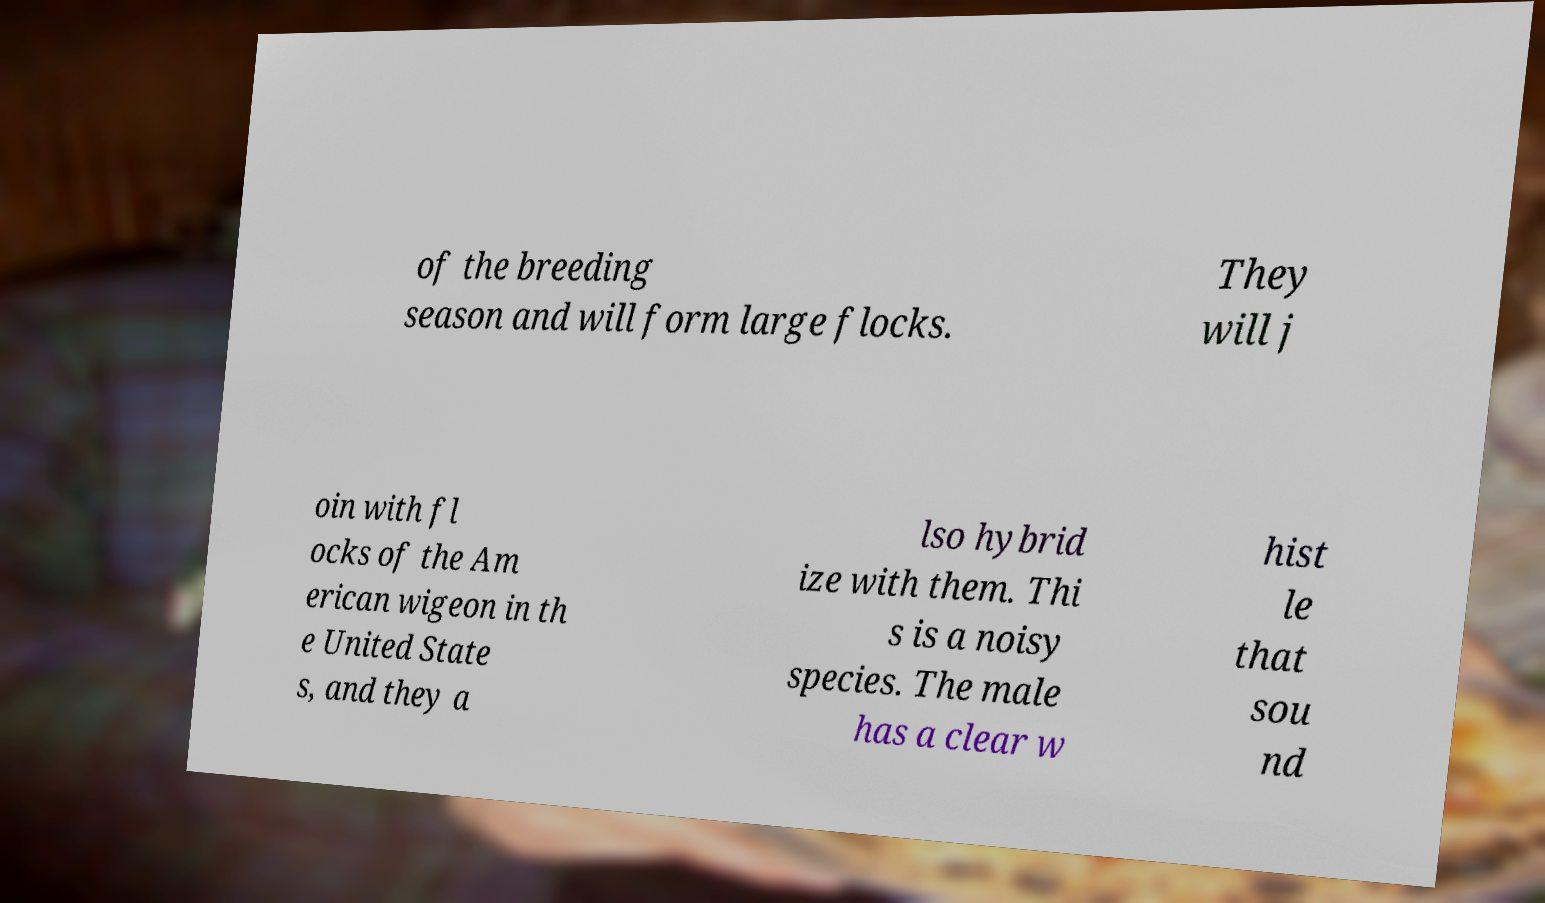Please identify and transcribe the text found in this image. of the breeding season and will form large flocks. They will j oin with fl ocks of the Am erican wigeon in th e United State s, and they a lso hybrid ize with them. Thi s is a noisy species. The male has a clear w hist le that sou nd 